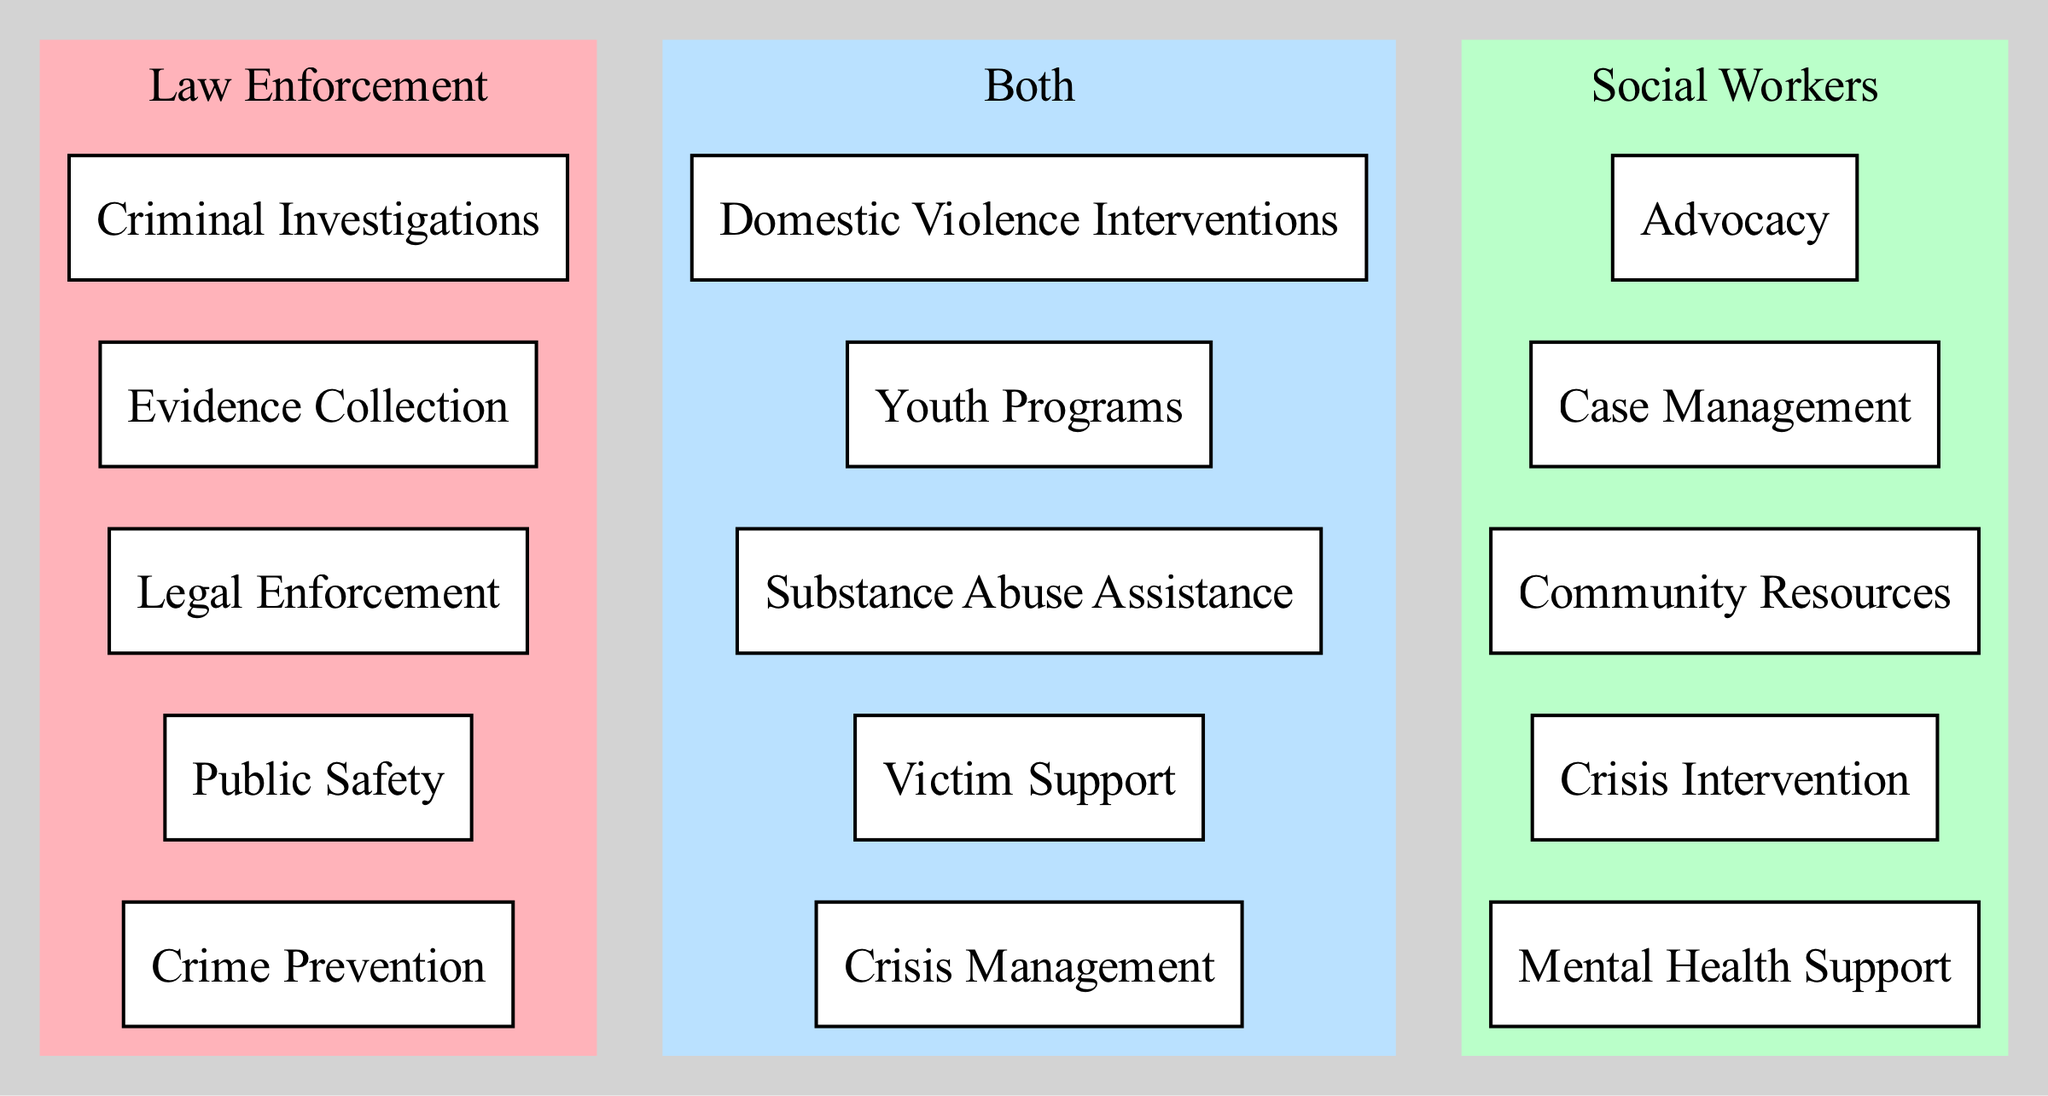What are the items listed under Law Enforcement? The diagram shows five items listed under Law Enforcement: Crime Prevention, Public Safety, Legal Enforcement, Evidence Collection, and Criminal Investigations. This can be determined by looking at the designated section for Law Enforcement in the Venn diagram.
Answer: Crime Prevention, Public Safety, Legal Enforcement, Evidence Collection, Criminal Investigations What are the overlapping roles shared by both Law Enforcement and Social Workers? The diagram indicates that there are five roles shared by both Law Enforcement and Social Workers: Crisis Management, Victim Support, Substance Abuse Assistance, Youth Programs, and Domestic Violence Interventions. This information is obtained from the central area where the two circles intersect in the Venn diagram.
Answer: Crisis Management, Victim Support, Substance Abuse Assistance, Youth Programs, Domestic Violence Interventions How many items are listed under Social Workers? There are five items listed under Social Workers in the diagram: Mental Health Support, Crisis Intervention, Community Resources, Case Management, and Advocacy. This can be seen in the section dedicated to Social Workers of the Venn diagram.
Answer: 5 Which role specifically addresses the needs of victims? The diagram lists "Victim Support" as one of the overlapping roles between Law Enforcement and Social Workers. By examining the common area of the Venn diagram, this role can be identified clearly.
Answer: Victim Support Do both Law Enforcement and Social Workers provide crisis management? Yes, the role of Crisis Management is shared by both Law Enforcement and Social Workers, as displayed in the overlap section of the Venn diagram. Both professions contribute to this aspect, accommodating diverse community needs.
Answer: Yes Which organization is primarily responsible for mental health support? According to the diagram, Mental Health Support is listed under the Social Workers' section. This indicates that Social Workers have the primary responsibility for providing this type of support, unlike roles pertaining to Law Enforcement.
Answer: Social Workers How many unique roles are listed under Law Enforcement? The diagram specifies five unique roles under Law Enforcement: Crime Prevention, Public Safety, Legal Enforcement, Evidence Collection, and Criminal Investigations, visible in the Law Enforcement section of the Venn diagram.
Answer: 5 Which two roles are directly related to substance issues? The diagram identifies "Substance Abuse Assistance" in the overlapping roles, indicating it involves both Law Enforcement and Social Workers. This shared responsibility shows the collaborative approach to addressing substance issues within the community.
Answer: Substance Abuse Assistance What role focuses on advocacy? The role of Advocacy is listed under Social Workers in the Venn diagram. By referring to the distinct section for Social Workers, one can clearly see this specific role is part of their responsibilities.
Answer: Advocacy 